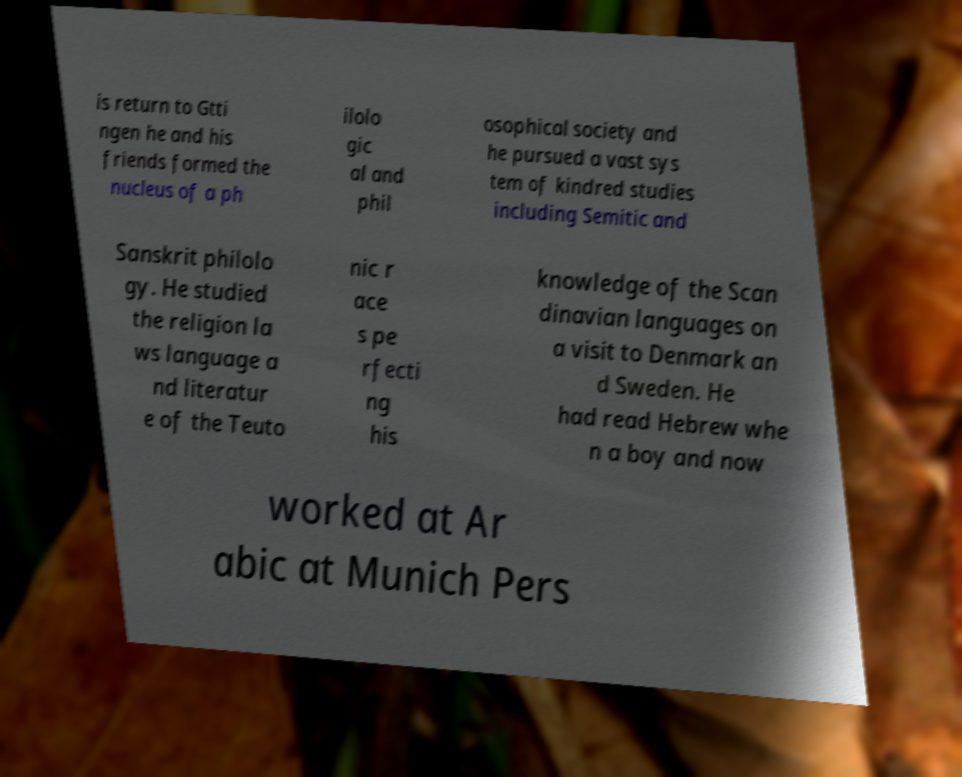Could you assist in decoding the text presented in this image and type it out clearly? is return to Gtti ngen he and his friends formed the nucleus of a ph ilolo gic al and phil osophical society and he pursued a vast sys tem of kindred studies including Semitic and Sanskrit philolo gy. He studied the religion la ws language a nd literatur e of the Teuto nic r ace s pe rfecti ng his knowledge of the Scan dinavian languages on a visit to Denmark an d Sweden. He had read Hebrew whe n a boy and now worked at Ar abic at Munich Pers 